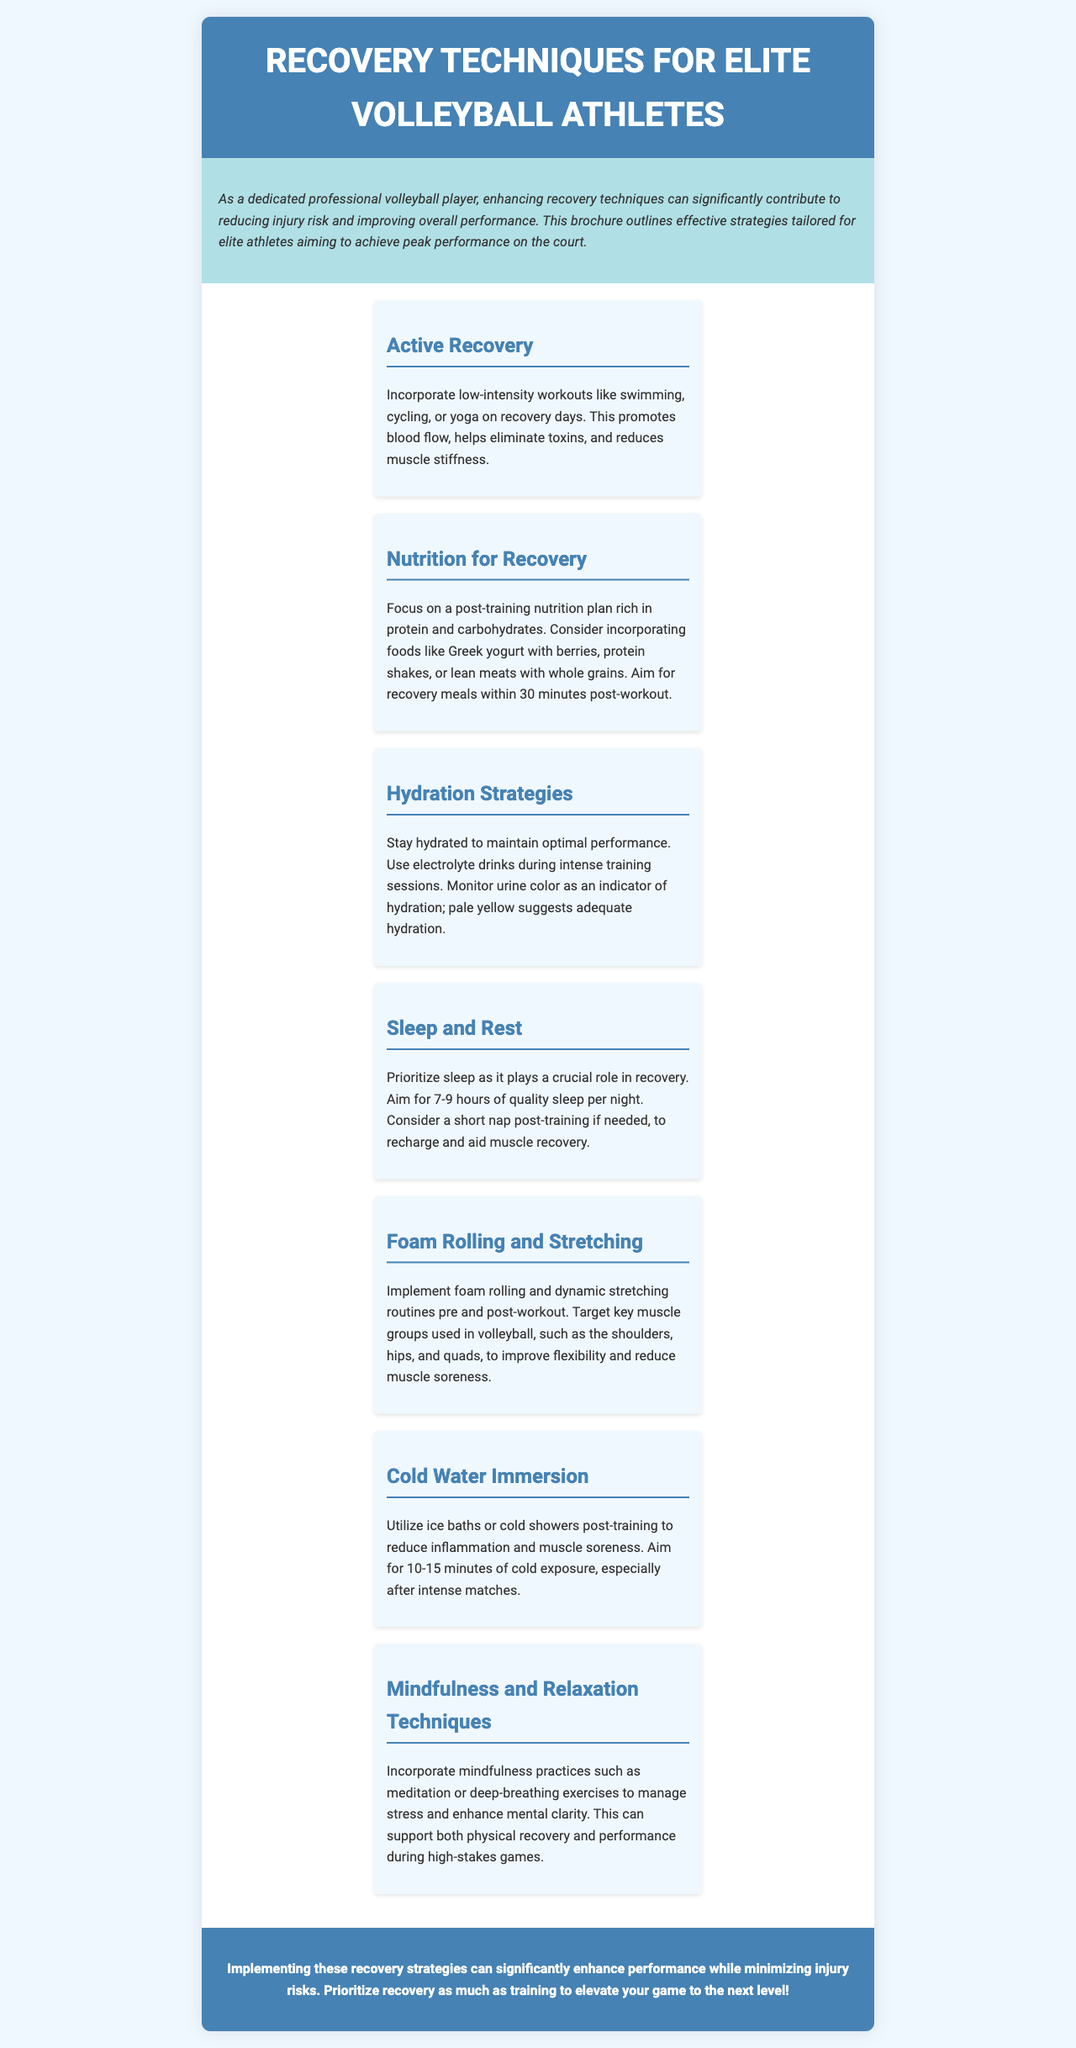What is the title of the brochure? The title of the brochure is mentioned at the top of the document, indicating its focus on recovery techniques for volleyball athletes.
Answer: Recovery Techniques for Elite Volleyball Athletes How many hours of sleep are recommended per night? The document specifies a recommended sleep duration for optimal recovery based on previous sections discussing sleep importance.
Answer: 7-9 hours What type of workouts are suggested for active recovery? The document lists specific activities that promote active recovery as mentioned in the corresponding section.
Answer: Swimming, cycling, or yoga What should be included in post-training nutrition? The brochure describes recommended foods that contribute to recovery after training sessions.
Answer: Protein and carbohydrates How long should cold water immersion last? The document advises on the duration for cold water exposure post-training based on recommendations provided in the recovery section.
Answer: 10-15 minutes Identify a technique for mental recovery mentioned in the document. The brochure points out a specific practice designed to aid in mental clarity and stress management, relevant to athletes.
Answer: Mindfulness practices What is the primary benefit of foam rolling? The benefit of foam rolling is discussed in terms of its impact on muscle groups utilized in volleyball, addressing flexibility and soreness.
Answer: Improve flexibility During intense training, what drinks are recommended for hydration? The document suggests what type of beverages should be used during training to maintain hydration levels.
Answer: Electrolyte drinks 